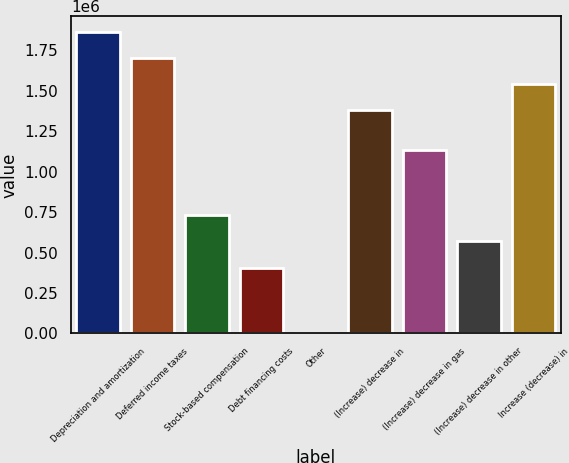<chart> <loc_0><loc_0><loc_500><loc_500><bar_chart><fcel>Depreciation and amortization<fcel>Deferred income taxes<fcel>Stock-based compensation<fcel>Debt financing costs<fcel>Other<fcel>(Increase) decrease in<fcel>(Increase) decrease in gas<fcel>(Increase) decrease in other<fcel>Increase (decrease) in<nl><fcel>1.86694e+06<fcel>1.70462e+06<fcel>730758<fcel>406136<fcel>359<fcel>1.38e+06<fcel>1.13654e+06<fcel>568448<fcel>1.54231e+06<nl></chart> 